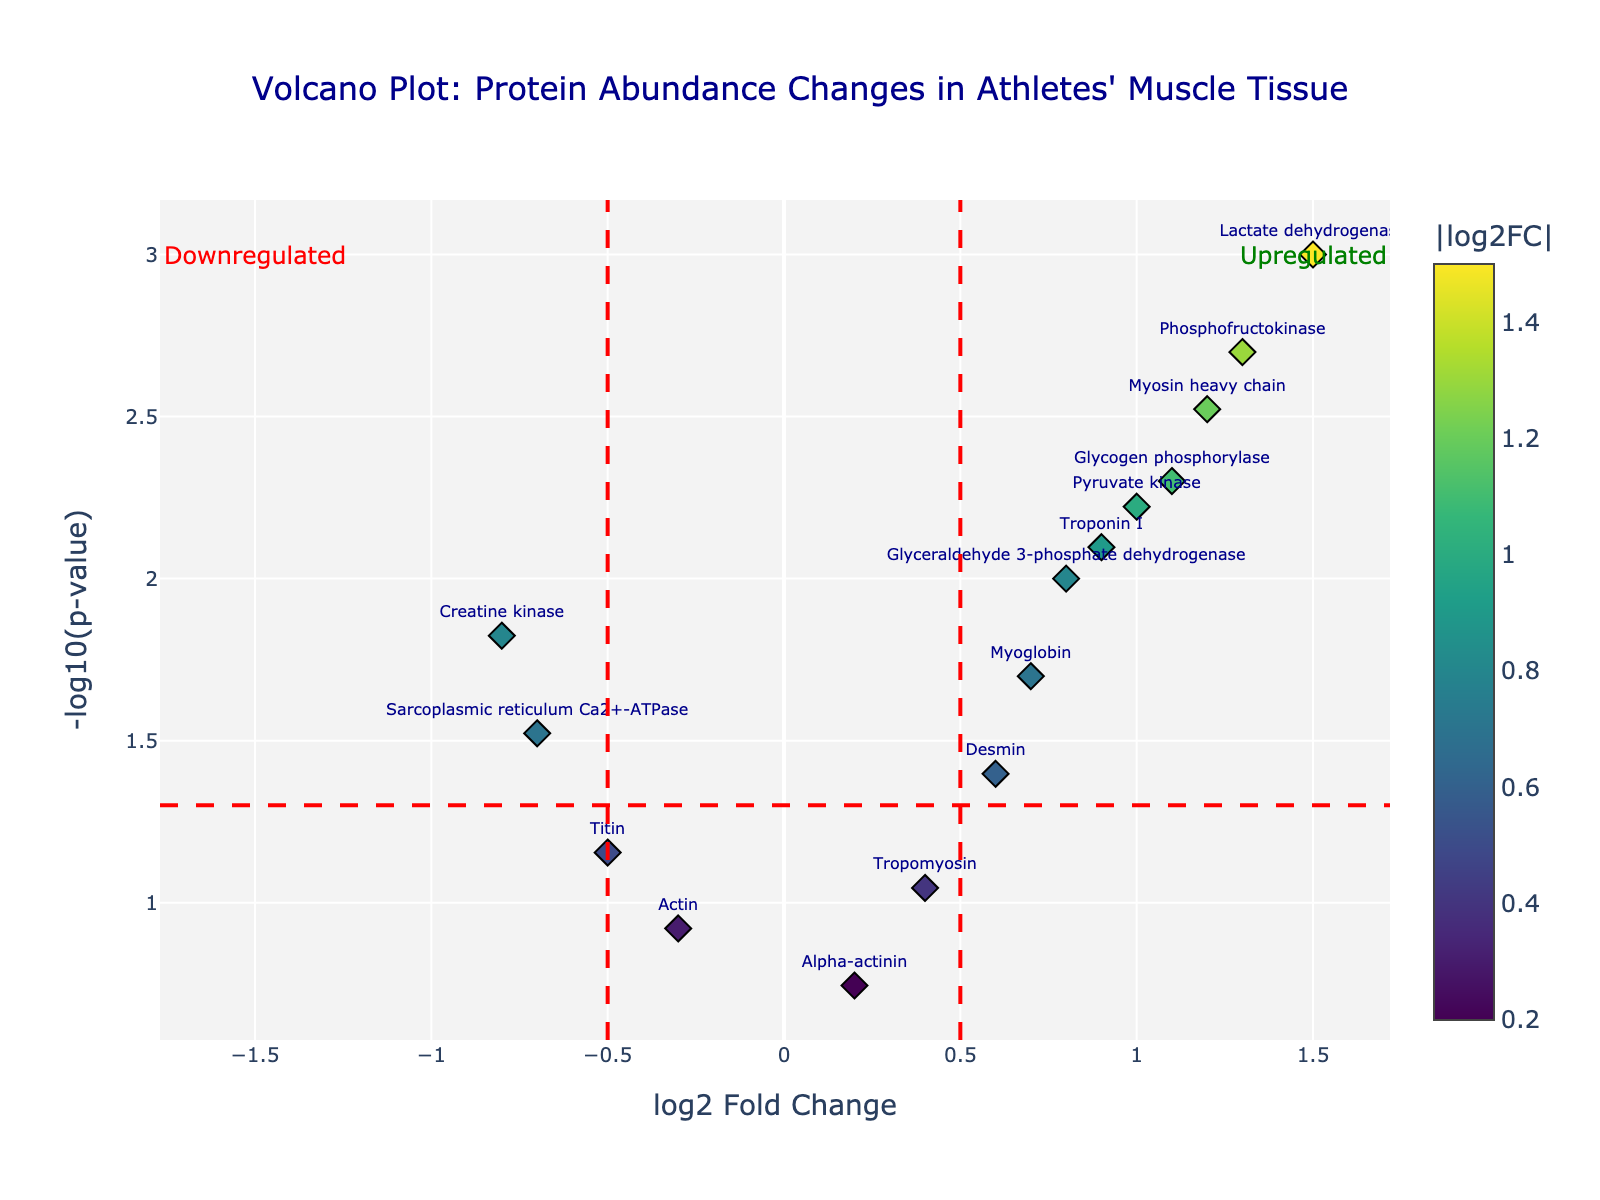What's the title of the figure? The title of the figure can be found at the top center of the plot. It provides a short description of what the plot is about. The title is "Volcano Plot: Protein Abundance Changes in Athletes' Muscle Tissue".
Answer: Volcano Plot: Protein Abundance Changes in Athletes' Muscle Tissue How many proteins showed significant changes in abundance (p-value < 0.05)? Significant changes in abundance for proteins are marked by p-values less than 0.05, represented by points above the red dashed horizontal line at y = -log10(0.05). Counting these points will give the answer. There are 11 proteins above this threshold.
Answer: 11 Which protein has the highest log2 fold change? The protein with the highest log2 fold change is identified by the furthest point to the right on the x-axis. From the data, Lactate dehydrogenase has the highest log2 fold change of 1.5.
Answer: Lactate dehydrogenase What is the log2 fold change of Troponin I, and is it upregulated or downregulated? To determine if Troponin I is upregulated or downregulated, look at the log2 fold change. A positive value indicates upregulation, and a negative value indicates downregulation. Troponin I has a log2 fold change of 0.9, indicating it is upregulated.
Answer: 0.9, upregulated Which proteins are considered downregulated with significant p-values? Proteins are downregulated if they have a negative log2 fold change and are considered significant if their p-values are less than 0.05. From the data, each protein with a log2 fold change less than zero and a p-value less than 0.05 includes Sarcoplasmic reticulum Ca2+-ATPase and Creatine kinase.
Answer: Sarcoplasmic reticulum Ca2+-ATPase, Creatine kinase Are there any proteins that are neither significantly upregulated nor downregulated? Proteins that are neither significantly upregulated nor downregulated will have a p-value above 0.05 or a log2 fold change within the thresholds of -0.5 to 0.5. From the data, Actin, Tropomyosin, Titin, and Alpha-actinin meet this condition.
Answer: Actin, Tropomyosin, Titin, Alpha-actinin What trends can you deduce from the placement of the proteins on the plot (with regard to upregulation and downregulation)? Proteins with high log2 fold change values to the right are upregulated, while those to the left with negative log2 fold change values are downregulated. Those above the red dashed line have significant p-values showing strong changes in protein abundance. It is noticeable that more proteins are upregulated post-competition since more points are located on the right.
Answer: More proteins are upregulated post-competition 